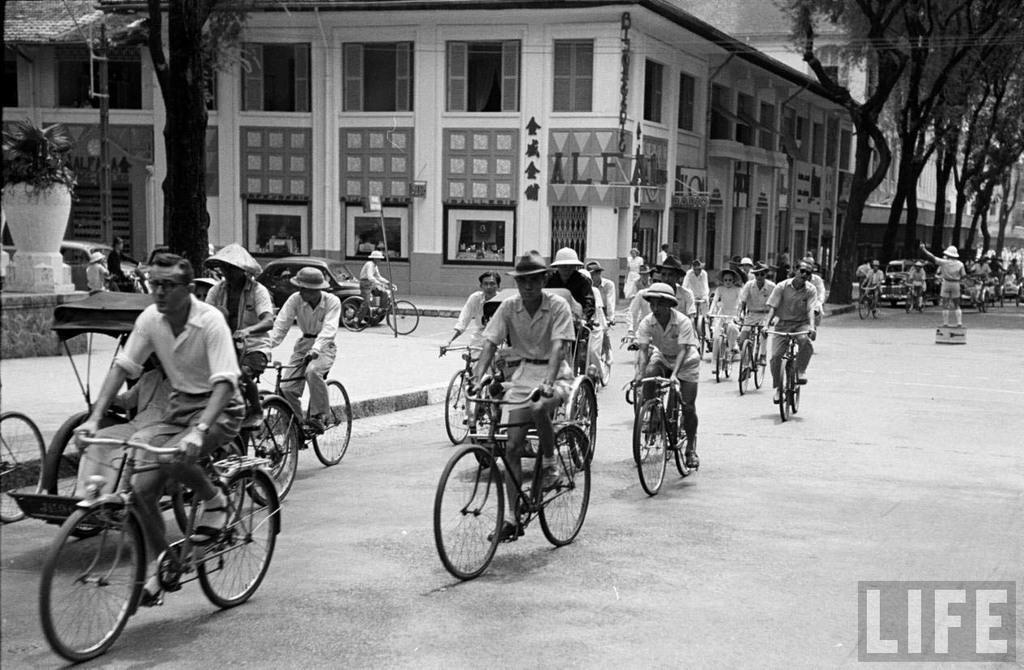Could you give a brief overview of what you see in this image? Here we can see a group of people riding bicycles and behind them we can see building, cars and trees present 